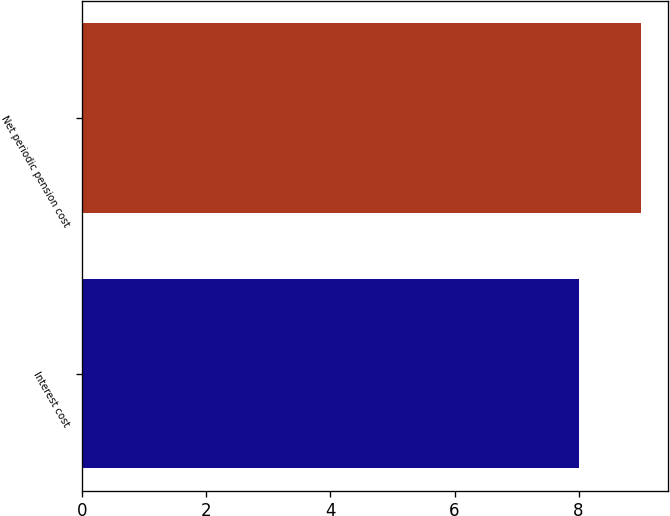Convert chart. <chart><loc_0><loc_0><loc_500><loc_500><bar_chart><fcel>Interest cost<fcel>Net periodic pension cost<nl><fcel>8<fcel>9<nl></chart> 